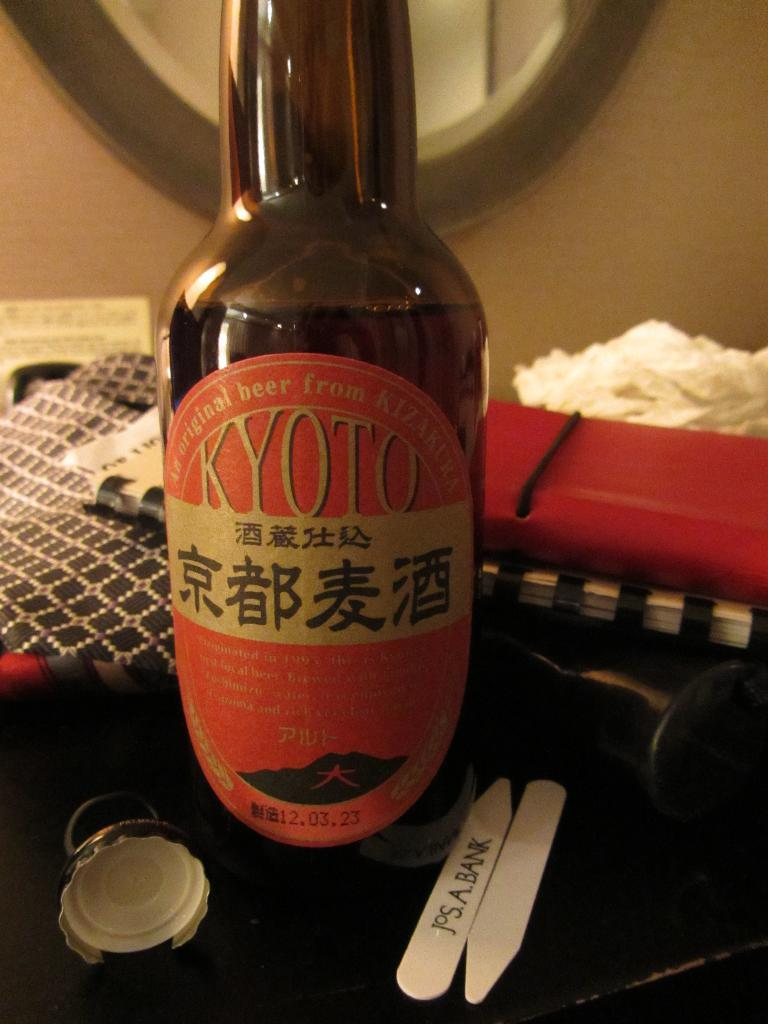Provide a one-sentence caption for the provided image. A bottle of Japanese beer that reads KYOTO on the front. 